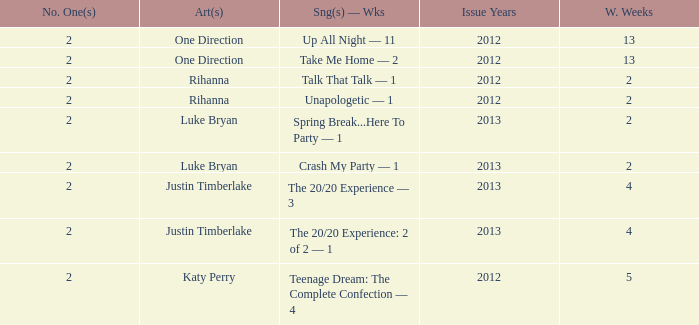What is the title of every song, and how many weeks was each song at #1 for One Direction? Up All Night — 11, Take Me Home — 2. 